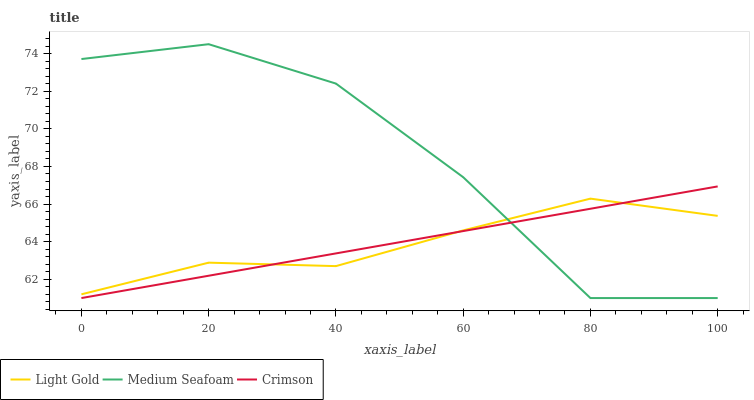Does Light Gold have the minimum area under the curve?
Answer yes or no. Yes. Does Medium Seafoam have the maximum area under the curve?
Answer yes or no. Yes. Does Medium Seafoam have the minimum area under the curve?
Answer yes or no. No. Does Light Gold have the maximum area under the curve?
Answer yes or no. No. Is Crimson the smoothest?
Answer yes or no. Yes. Is Medium Seafoam the roughest?
Answer yes or no. Yes. Is Light Gold the smoothest?
Answer yes or no. No. Is Light Gold the roughest?
Answer yes or no. No. Does Crimson have the lowest value?
Answer yes or no. Yes. Does Light Gold have the lowest value?
Answer yes or no. No. Does Medium Seafoam have the highest value?
Answer yes or no. Yes. Does Light Gold have the highest value?
Answer yes or no. No. Does Light Gold intersect Crimson?
Answer yes or no. Yes. Is Light Gold less than Crimson?
Answer yes or no. No. Is Light Gold greater than Crimson?
Answer yes or no. No. 